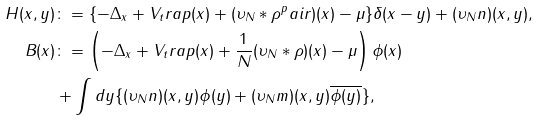Convert formula to latex. <formula><loc_0><loc_0><loc_500><loc_500>H ( x , y ) & \colon = \{ - \Delta _ { x } + V _ { t } r a p ( x ) + ( \upsilon _ { N } \ast \rho ^ { p } a i r ) ( x ) - \mu \} \delta ( x - y ) + ( \upsilon _ { N } n ) ( x , y ) , \\ B ( x ) & \colon = \left ( - \Delta _ { x } + V _ { t } r a p ( x ) + \frac { 1 } { N } ( \upsilon _ { N } \ast \rho ) ( x ) - \mu \right ) \phi ( x ) \\ & + \int { d y \{ ( \upsilon _ { N } n ) ( x , y ) \phi ( y ) + ( \upsilon _ { N } m ) ( x , y ) \overline { \phi ( y ) } \} } ,</formula> 